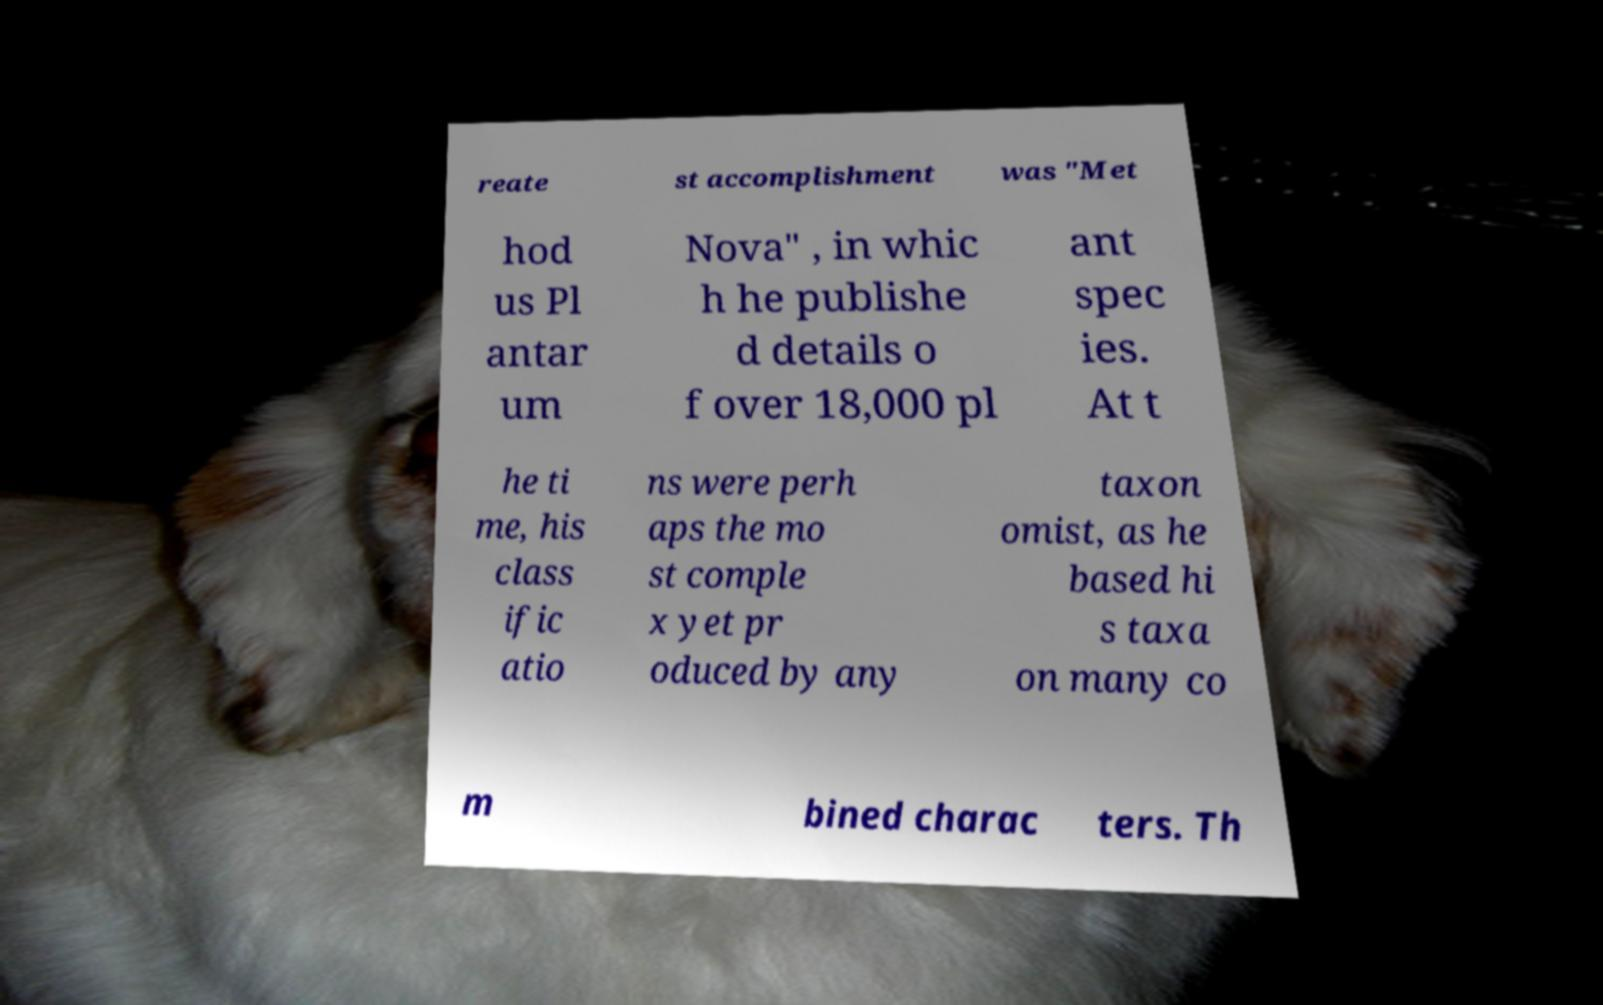Please read and relay the text visible in this image. What does it say? reate st accomplishment was "Met hod us Pl antar um Nova" , in whic h he publishe d details o f over 18,000 pl ant spec ies. At t he ti me, his class ific atio ns were perh aps the mo st comple x yet pr oduced by any taxon omist, as he based hi s taxa on many co m bined charac ters. Th 